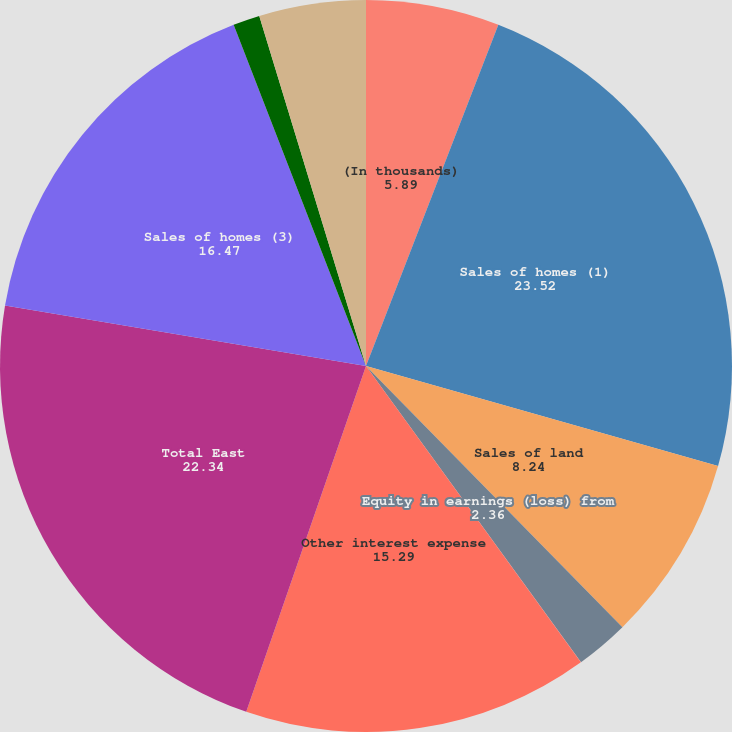Convert chart. <chart><loc_0><loc_0><loc_500><loc_500><pie_chart><fcel>(In thousands)<fcel>Sales of homes (1)<fcel>Sales of land<fcel>Equity in earnings (loss) from<fcel>Other income (expense) net (2)<fcel>Other interest expense<fcel>Total East<fcel>Sales of homes (3)<fcel>Equity in loss from<fcel>Other expense net<nl><fcel>5.89%<fcel>23.52%<fcel>8.24%<fcel>2.36%<fcel>0.01%<fcel>15.29%<fcel>22.34%<fcel>16.47%<fcel>1.18%<fcel>4.71%<nl></chart> 